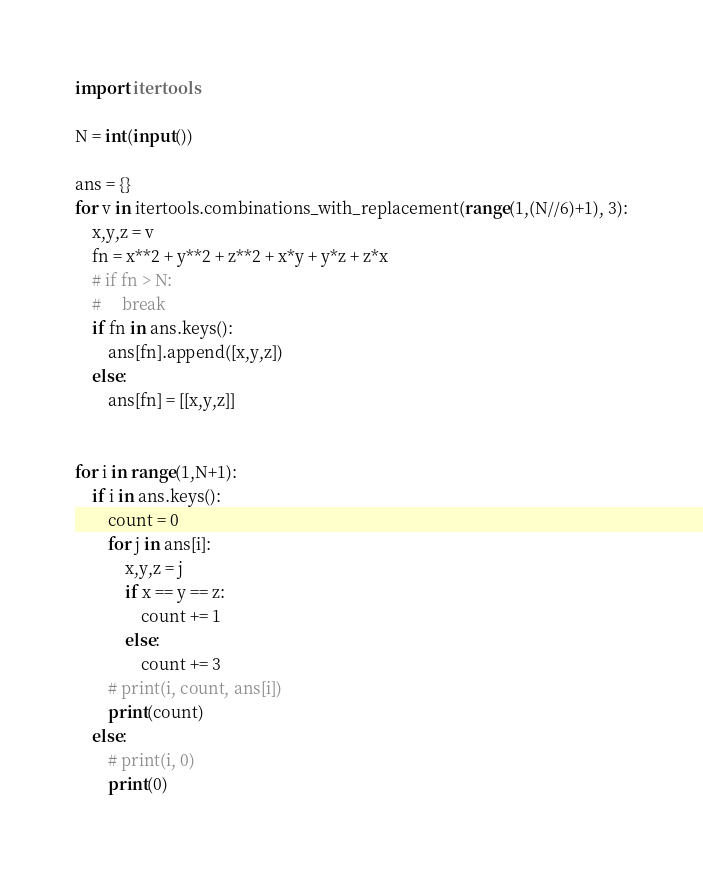Convert code to text. <code><loc_0><loc_0><loc_500><loc_500><_Python_>import itertools

N = int(input())

ans = {}
for v in itertools.combinations_with_replacement(range(1,(N//6)+1), 3):
    x,y,z = v
    fn = x**2 + y**2 + z**2 + x*y + y*z + z*x
    # if fn > N:
    #     break
    if fn in ans.keys():
        ans[fn].append([x,y,z])
    else:
        ans[fn] = [[x,y,z]]


for i in range(1,N+1):
    if i in ans.keys():
        count = 0
        for j in ans[i]:
            x,y,z = j
            if x == y == z:
                count += 1
            else:
                count += 3
        # print(i, count, ans[i])
        print(count)
    else:
        # print(i, 0)
        print(0)
</code> 